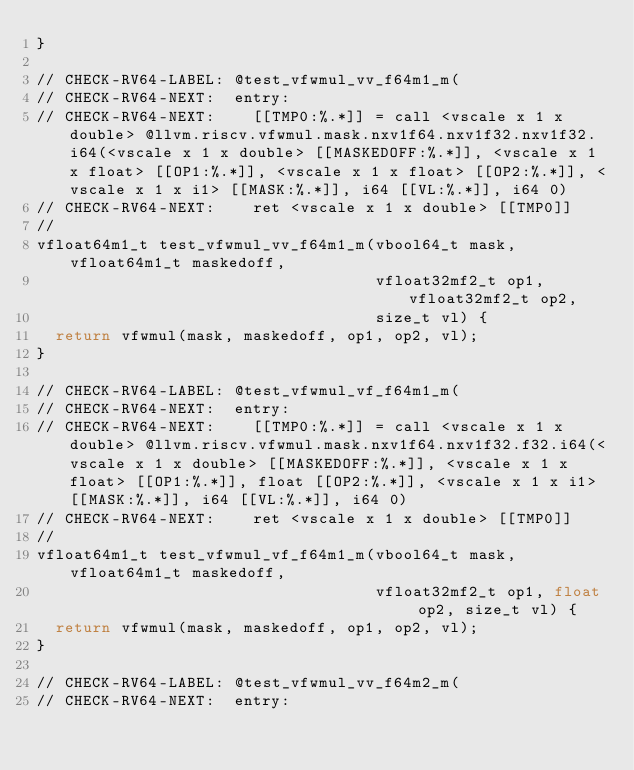<code> <loc_0><loc_0><loc_500><loc_500><_C_>}

// CHECK-RV64-LABEL: @test_vfwmul_vv_f64m1_m(
// CHECK-RV64-NEXT:  entry:
// CHECK-RV64-NEXT:    [[TMP0:%.*]] = call <vscale x 1 x double> @llvm.riscv.vfwmul.mask.nxv1f64.nxv1f32.nxv1f32.i64(<vscale x 1 x double> [[MASKEDOFF:%.*]], <vscale x 1 x float> [[OP1:%.*]], <vscale x 1 x float> [[OP2:%.*]], <vscale x 1 x i1> [[MASK:%.*]], i64 [[VL:%.*]], i64 0)
// CHECK-RV64-NEXT:    ret <vscale x 1 x double> [[TMP0]]
//
vfloat64m1_t test_vfwmul_vv_f64m1_m(vbool64_t mask, vfloat64m1_t maskedoff,
                                    vfloat32mf2_t op1, vfloat32mf2_t op2,
                                    size_t vl) {
  return vfwmul(mask, maskedoff, op1, op2, vl);
}

// CHECK-RV64-LABEL: @test_vfwmul_vf_f64m1_m(
// CHECK-RV64-NEXT:  entry:
// CHECK-RV64-NEXT:    [[TMP0:%.*]] = call <vscale x 1 x double> @llvm.riscv.vfwmul.mask.nxv1f64.nxv1f32.f32.i64(<vscale x 1 x double> [[MASKEDOFF:%.*]], <vscale x 1 x float> [[OP1:%.*]], float [[OP2:%.*]], <vscale x 1 x i1> [[MASK:%.*]], i64 [[VL:%.*]], i64 0)
// CHECK-RV64-NEXT:    ret <vscale x 1 x double> [[TMP0]]
//
vfloat64m1_t test_vfwmul_vf_f64m1_m(vbool64_t mask, vfloat64m1_t maskedoff,
                                    vfloat32mf2_t op1, float op2, size_t vl) {
  return vfwmul(mask, maskedoff, op1, op2, vl);
}

// CHECK-RV64-LABEL: @test_vfwmul_vv_f64m2_m(
// CHECK-RV64-NEXT:  entry:</code> 